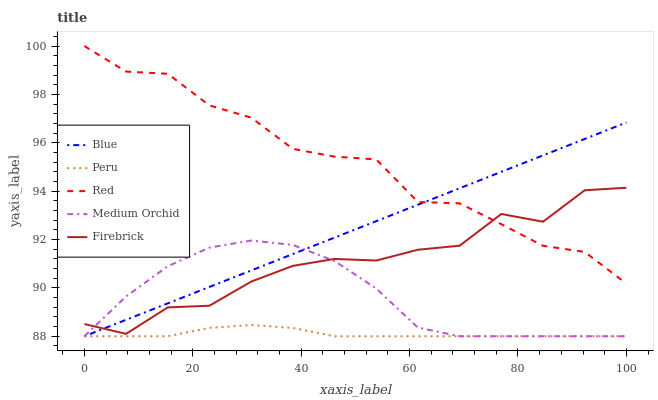Does Peru have the minimum area under the curve?
Answer yes or no. Yes. Does Red have the maximum area under the curve?
Answer yes or no. Yes. Does Firebrick have the minimum area under the curve?
Answer yes or no. No. Does Firebrick have the maximum area under the curve?
Answer yes or no. No. Is Blue the smoothest?
Answer yes or no. Yes. Is Firebrick the roughest?
Answer yes or no. Yes. Is Medium Orchid the smoothest?
Answer yes or no. No. Is Medium Orchid the roughest?
Answer yes or no. No. Does Blue have the lowest value?
Answer yes or no. Yes. Does Firebrick have the lowest value?
Answer yes or no. No. Does Red have the highest value?
Answer yes or no. Yes. Does Firebrick have the highest value?
Answer yes or no. No. Is Peru less than Red?
Answer yes or no. Yes. Is Red greater than Medium Orchid?
Answer yes or no. Yes. Does Firebrick intersect Red?
Answer yes or no. Yes. Is Firebrick less than Red?
Answer yes or no. No. Is Firebrick greater than Red?
Answer yes or no. No. Does Peru intersect Red?
Answer yes or no. No. 